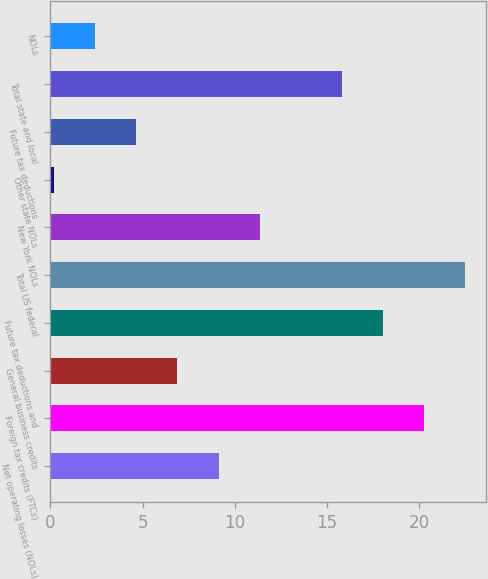Convert chart to OTSL. <chart><loc_0><loc_0><loc_500><loc_500><bar_chart><fcel>Net operating losses (NOLs)<fcel>Foreign tax credits (FTCs)<fcel>General business credits<fcel>Future tax deductions and<fcel>Total US federal<fcel>New York NOLs<fcel>Other state NOLs<fcel>Future tax deductions<fcel>Total state and local<fcel>NOLs<nl><fcel>9.12<fcel>20.27<fcel>6.89<fcel>18.04<fcel>22.5<fcel>11.35<fcel>0.2<fcel>4.66<fcel>15.81<fcel>2.43<nl></chart> 